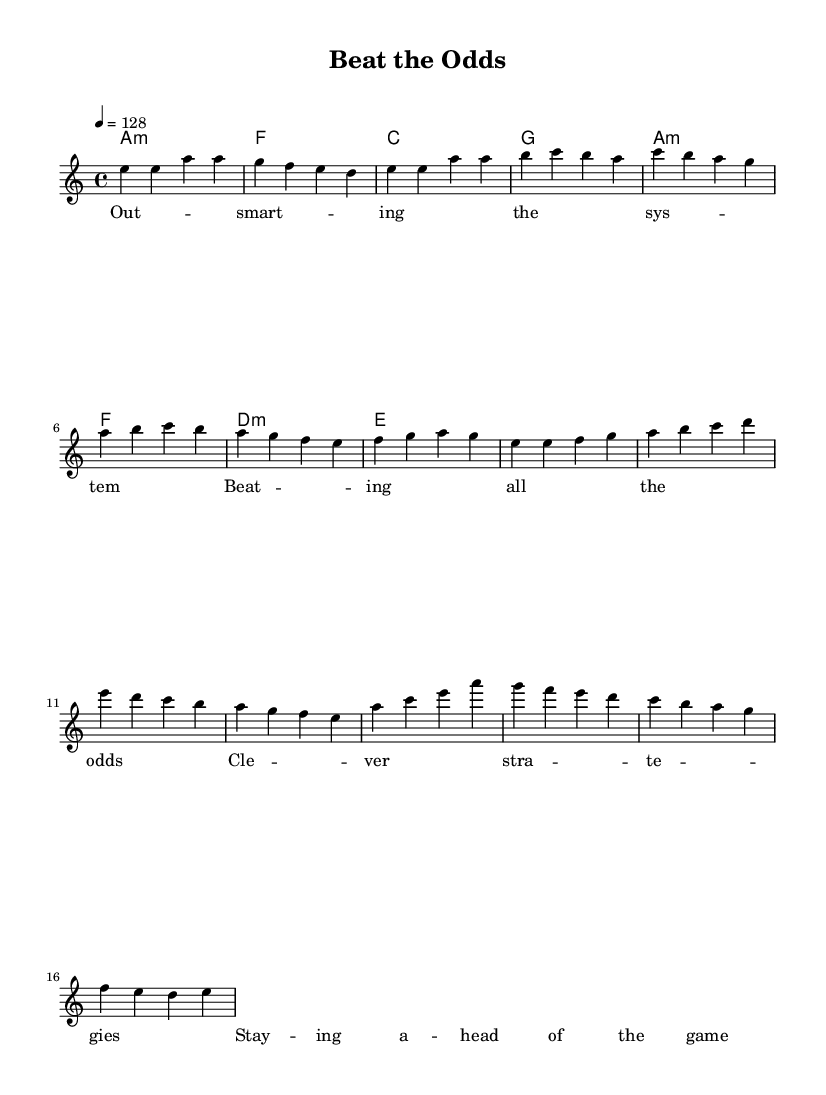What is the key signature of this music? The key signature is A minor, which has no sharps or flats and is indicated by the absence of any sharp or flat signs at the beginning of the staff.
Answer: A minor What is the time signature of this music? The time signature is 4/4, which indicates that there are four beats in each measure and a quarter note receives one beat. This is visually indicated at the beginning of the staff.
Answer: 4/4 What is the tempo marking for this piece? The tempo marking is 128 beats per minute, specified near the beginning of the score with the instructions to play at this speed.
Answer: 128 How many bars are in the chorus section? The chorus section consists of four bars, which can be counted and verified by examining the measures labeled with the melody.
Answer: 4 What is the lyrical theme of this song? The lyrical theme revolves around outsmarting systems and clever strategies, as inferred from the title and content of the lyrics.
Answer: Outsmarting the system Which chord follows the melody in the pre-chorus? The chord that follows the melody in the pre-chorus is D minor, as shown in the chord section corresponding to the measures where the pre-chorus melody occurs.
Answer: D minor What type of music does this piece represent? This piece represents fast-paced K-Pop dance music, indicated by the energetic tempo and lyrical content focused on strategies and competition.
Answer: K-Pop 